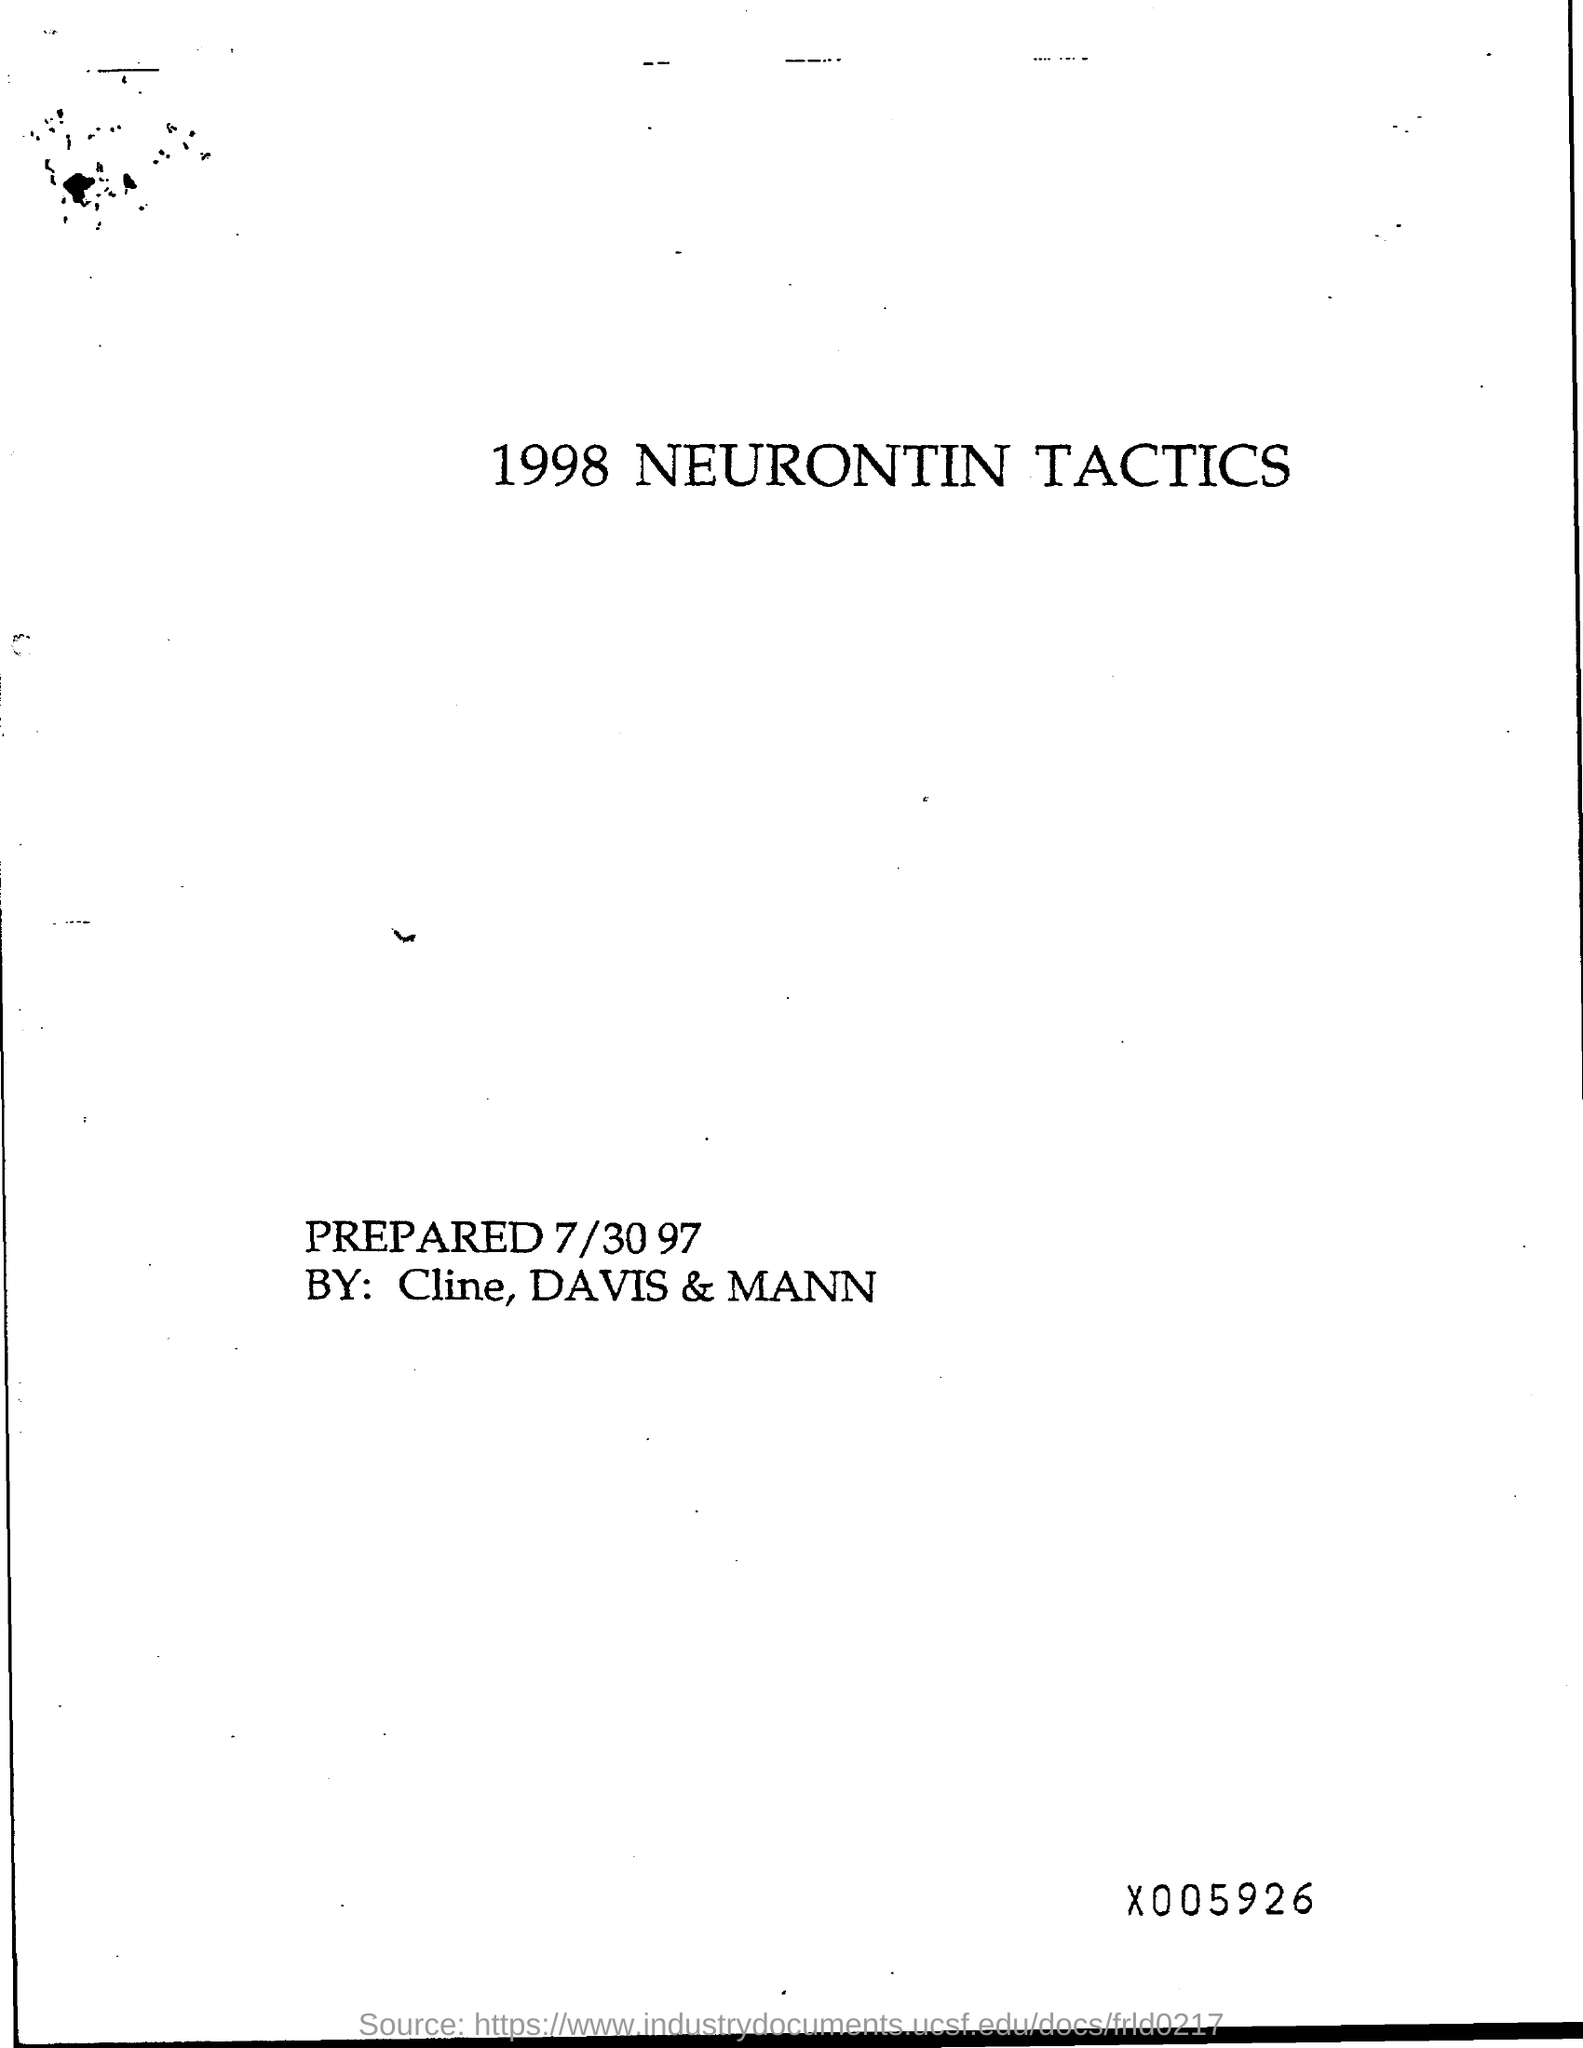What is the date on the page?
Give a very brief answer. 7/30 97. 